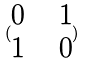<formula> <loc_0><loc_0><loc_500><loc_500>( \begin{matrix} 0 & & 1 \\ 1 & & 0 \end{matrix} )</formula> 